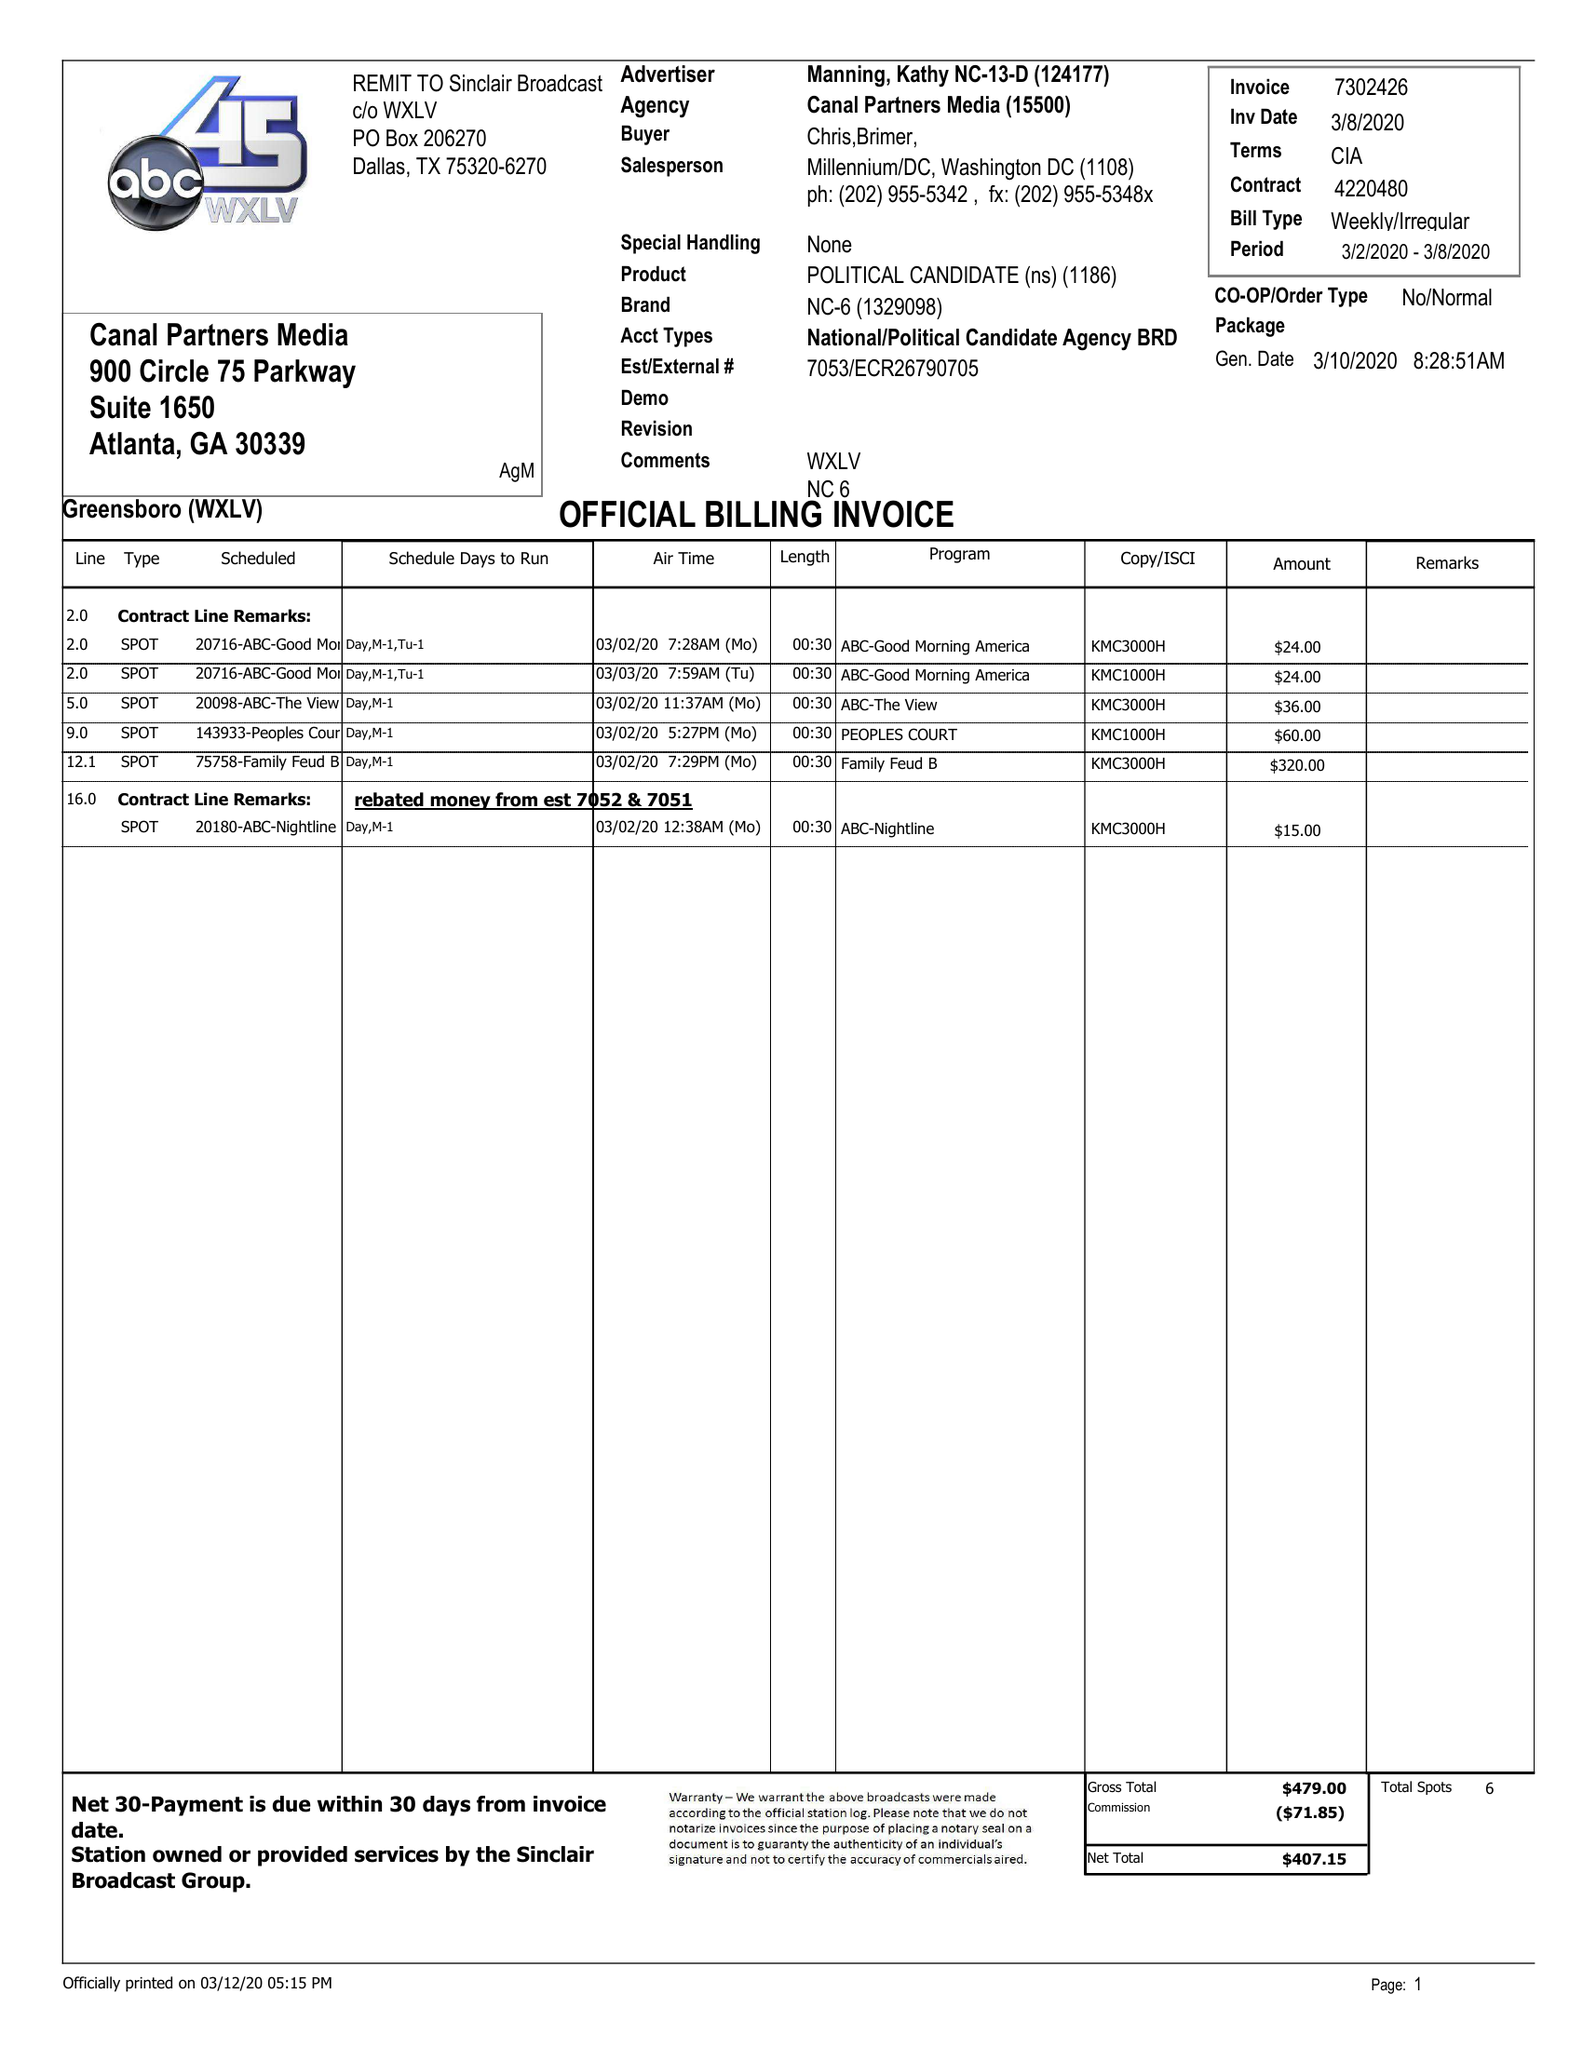What is the value for the gross_amount?
Answer the question using a single word or phrase. 479.00 